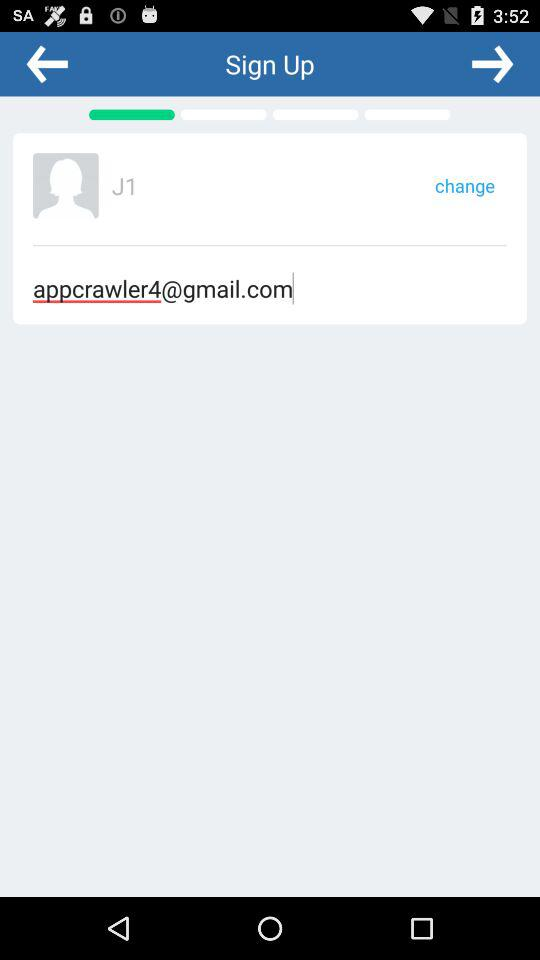What is the email address? The email address is appcrawler4@gmail.com. 